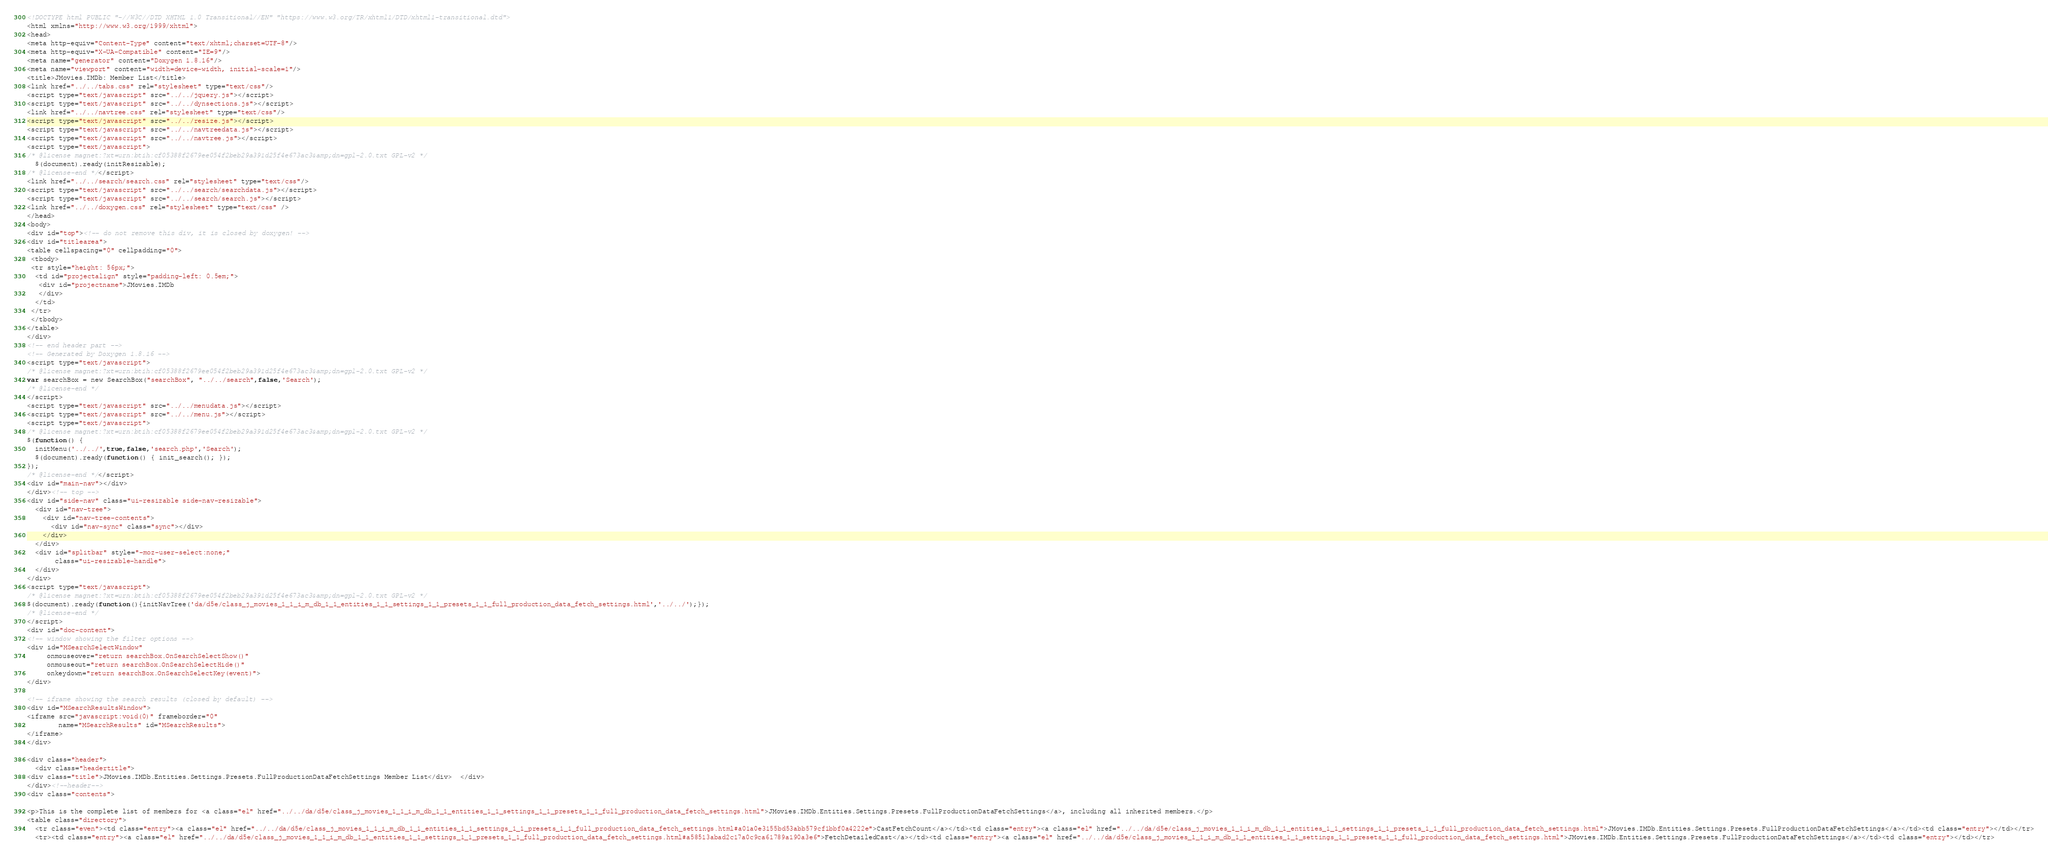<code> <loc_0><loc_0><loc_500><loc_500><_HTML_><!DOCTYPE html PUBLIC "-//W3C//DTD XHTML 1.0 Transitional//EN" "https://www.w3.org/TR/xhtml1/DTD/xhtml1-transitional.dtd">
<html xmlns="http://www.w3.org/1999/xhtml">
<head>
<meta http-equiv="Content-Type" content="text/xhtml;charset=UTF-8"/>
<meta http-equiv="X-UA-Compatible" content="IE=9"/>
<meta name="generator" content="Doxygen 1.8.16"/>
<meta name="viewport" content="width=device-width, initial-scale=1"/>
<title>JMovies.IMDb: Member List</title>
<link href="../../tabs.css" rel="stylesheet" type="text/css"/>
<script type="text/javascript" src="../../jquery.js"></script>
<script type="text/javascript" src="../../dynsections.js"></script>
<link href="../../navtree.css" rel="stylesheet" type="text/css"/>
<script type="text/javascript" src="../../resize.js"></script>
<script type="text/javascript" src="../../navtreedata.js"></script>
<script type="text/javascript" src="../../navtree.js"></script>
<script type="text/javascript">
/* @license magnet:?xt=urn:btih:cf05388f2679ee054f2beb29a391d25f4e673ac3&amp;dn=gpl-2.0.txt GPL-v2 */
  $(document).ready(initResizable);
/* @license-end */</script>
<link href="../../search/search.css" rel="stylesheet" type="text/css"/>
<script type="text/javascript" src="../../search/searchdata.js"></script>
<script type="text/javascript" src="../../search/search.js"></script>
<link href="../../doxygen.css" rel="stylesheet" type="text/css" />
</head>
<body>
<div id="top"><!-- do not remove this div, it is closed by doxygen! -->
<div id="titlearea">
<table cellspacing="0" cellpadding="0">
 <tbody>
 <tr style="height: 56px;">
  <td id="projectalign" style="padding-left: 0.5em;">
   <div id="projectname">JMovies.IMDb
   </div>
  </td>
 </tr>
 </tbody>
</table>
</div>
<!-- end header part -->
<!-- Generated by Doxygen 1.8.16 -->
<script type="text/javascript">
/* @license magnet:?xt=urn:btih:cf05388f2679ee054f2beb29a391d25f4e673ac3&amp;dn=gpl-2.0.txt GPL-v2 */
var searchBox = new SearchBox("searchBox", "../../search",false,'Search');
/* @license-end */
</script>
<script type="text/javascript" src="../../menudata.js"></script>
<script type="text/javascript" src="../../menu.js"></script>
<script type="text/javascript">
/* @license magnet:?xt=urn:btih:cf05388f2679ee054f2beb29a391d25f4e673ac3&amp;dn=gpl-2.0.txt GPL-v2 */
$(function() {
  initMenu('../../',true,false,'search.php','Search');
  $(document).ready(function() { init_search(); });
});
/* @license-end */</script>
<div id="main-nav"></div>
</div><!-- top -->
<div id="side-nav" class="ui-resizable side-nav-resizable">
  <div id="nav-tree">
    <div id="nav-tree-contents">
      <div id="nav-sync" class="sync"></div>
    </div>
  </div>
  <div id="splitbar" style="-moz-user-select:none;" 
       class="ui-resizable-handle">
  </div>
</div>
<script type="text/javascript">
/* @license magnet:?xt=urn:btih:cf05388f2679ee054f2beb29a391d25f4e673ac3&amp;dn=gpl-2.0.txt GPL-v2 */
$(document).ready(function(){initNavTree('da/d5e/class_j_movies_1_1_i_m_db_1_1_entities_1_1_settings_1_1_presets_1_1_full_production_data_fetch_settings.html','../../');});
/* @license-end */
</script>
<div id="doc-content">
<!-- window showing the filter options -->
<div id="MSearchSelectWindow"
     onmouseover="return searchBox.OnSearchSelectShow()"
     onmouseout="return searchBox.OnSearchSelectHide()"
     onkeydown="return searchBox.OnSearchSelectKey(event)">
</div>

<!-- iframe showing the search results (closed by default) -->
<div id="MSearchResultsWindow">
<iframe src="javascript:void(0)" frameborder="0" 
        name="MSearchResults" id="MSearchResults">
</iframe>
</div>

<div class="header">
  <div class="headertitle">
<div class="title">JMovies.IMDb.Entities.Settings.Presets.FullProductionDataFetchSettings Member List</div>  </div>
</div><!--header-->
<div class="contents">

<p>This is the complete list of members for <a class="el" href="../../da/d5e/class_j_movies_1_1_i_m_db_1_1_entities_1_1_settings_1_1_presets_1_1_full_production_data_fetch_settings.html">JMovies.IMDb.Entities.Settings.Presets.FullProductionDataFetchSettings</a>, including all inherited members.</p>
<table class="directory">
  <tr class="even"><td class="entry"><a class="el" href="../../da/d5e/class_j_movies_1_1_i_m_db_1_1_entities_1_1_settings_1_1_presets_1_1_full_production_data_fetch_settings.html#a01a0e3155bd53abb579cf1bbf0a4222e">CastFetchCount</a></td><td class="entry"><a class="el" href="../../da/d5e/class_j_movies_1_1_i_m_db_1_1_entities_1_1_settings_1_1_presets_1_1_full_production_data_fetch_settings.html">JMovies.IMDb.Entities.Settings.Presets.FullProductionDataFetchSettings</a></td><td class="entry"></td></tr>
  <tr><td class="entry"><a class="el" href="../../da/d5e/class_j_movies_1_1_i_m_db_1_1_entities_1_1_settings_1_1_presets_1_1_full_production_data_fetch_settings.html#a58513abad2c17a0c9ca61789a190a3e6">FetchDetailedCast</a></td><td class="entry"><a class="el" href="../../da/d5e/class_j_movies_1_1_i_m_db_1_1_entities_1_1_settings_1_1_presets_1_1_full_production_data_fetch_settings.html">JMovies.IMDb.Entities.Settings.Presets.FullProductionDataFetchSettings</a></td><td class="entry"></td></tr></code> 